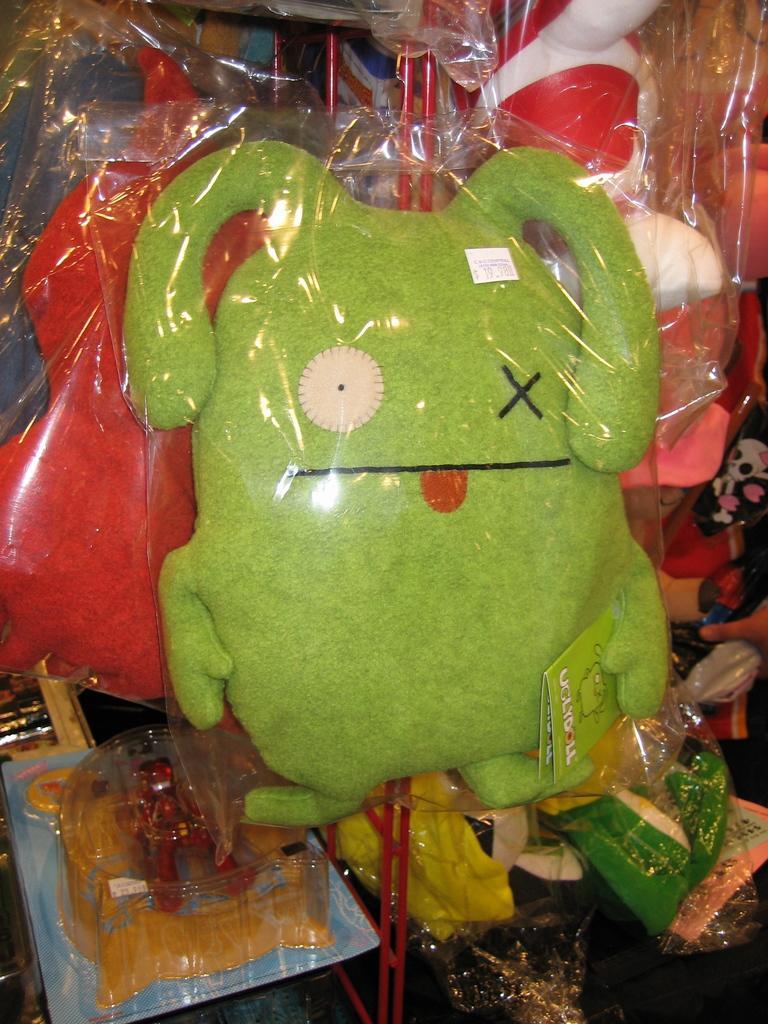Please provide a concise description of this image. Here we can see toys are in plastic covers. Front we can see green and red color toys. 